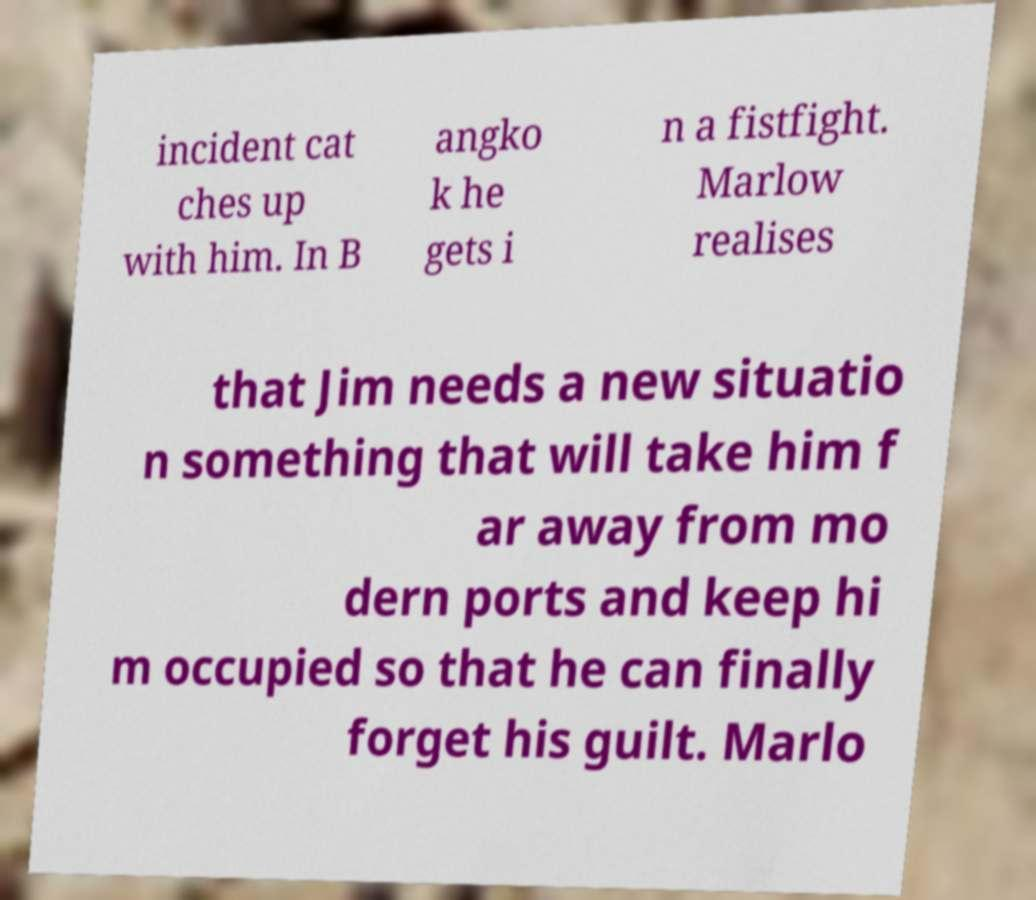There's text embedded in this image that I need extracted. Can you transcribe it verbatim? incident cat ches up with him. In B angko k he gets i n a fistfight. Marlow realises that Jim needs a new situatio n something that will take him f ar away from mo dern ports and keep hi m occupied so that he can finally forget his guilt. Marlo 